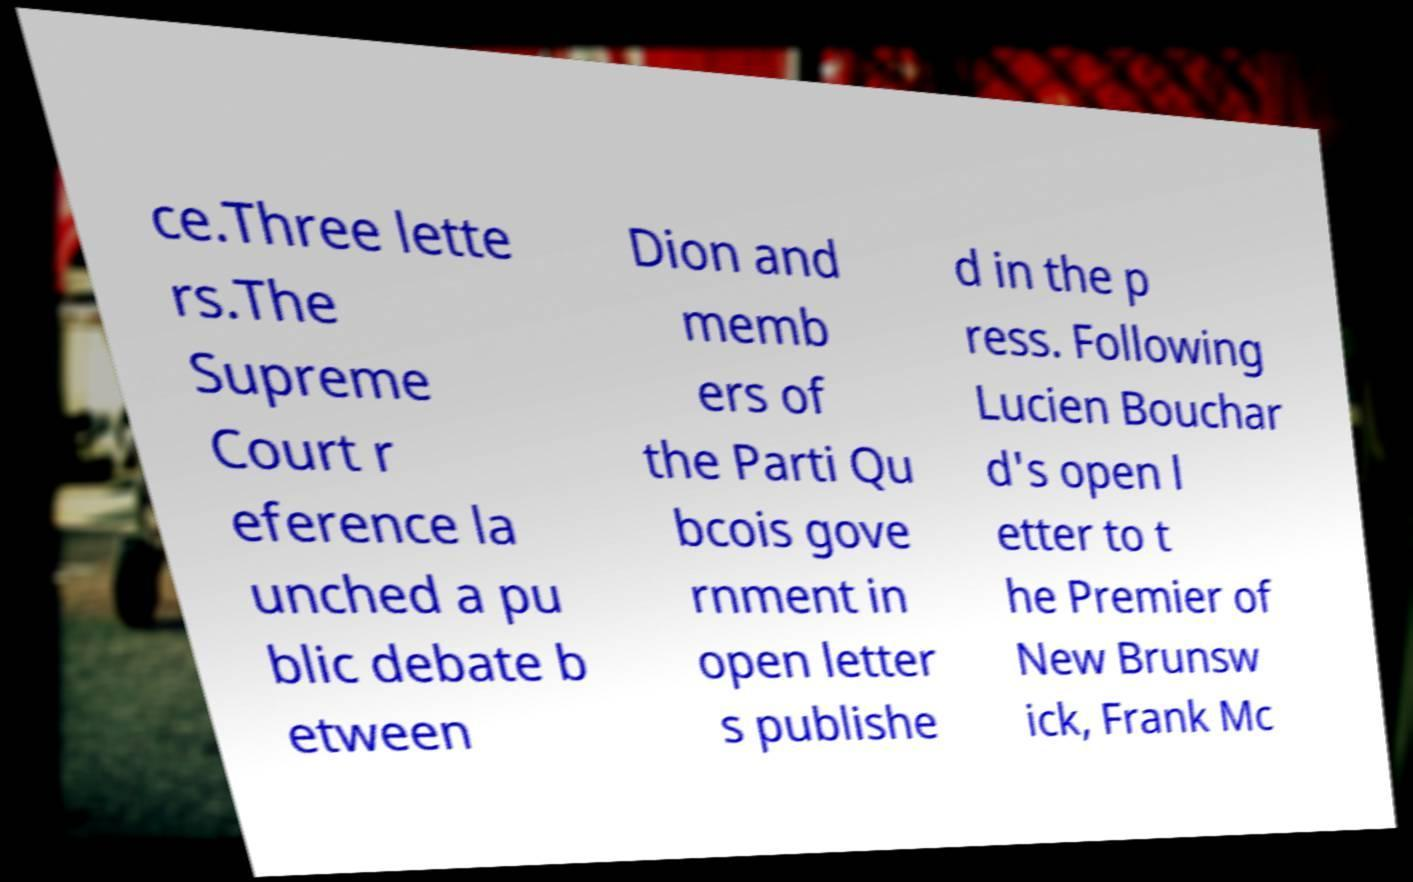For documentation purposes, I need the text within this image transcribed. Could you provide that? ce.Three lette rs.The Supreme Court r eference la unched a pu blic debate b etween Dion and memb ers of the Parti Qu bcois gove rnment in open letter s publishe d in the p ress. Following Lucien Bouchar d's open l etter to t he Premier of New Brunsw ick, Frank Mc 